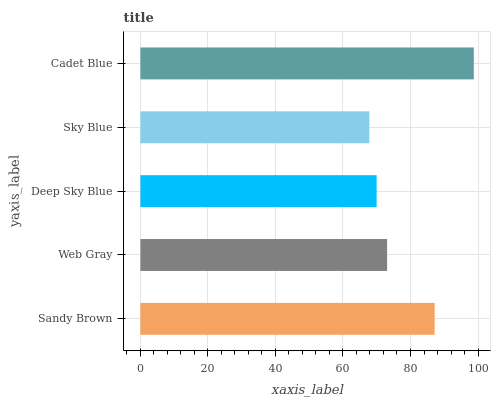Is Sky Blue the minimum?
Answer yes or no. Yes. Is Cadet Blue the maximum?
Answer yes or no. Yes. Is Web Gray the minimum?
Answer yes or no. No. Is Web Gray the maximum?
Answer yes or no. No. Is Sandy Brown greater than Web Gray?
Answer yes or no. Yes. Is Web Gray less than Sandy Brown?
Answer yes or no. Yes. Is Web Gray greater than Sandy Brown?
Answer yes or no. No. Is Sandy Brown less than Web Gray?
Answer yes or no. No. Is Web Gray the high median?
Answer yes or no. Yes. Is Web Gray the low median?
Answer yes or no. Yes. Is Sandy Brown the high median?
Answer yes or no. No. Is Deep Sky Blue the low median?
Answer yes or no. No. 